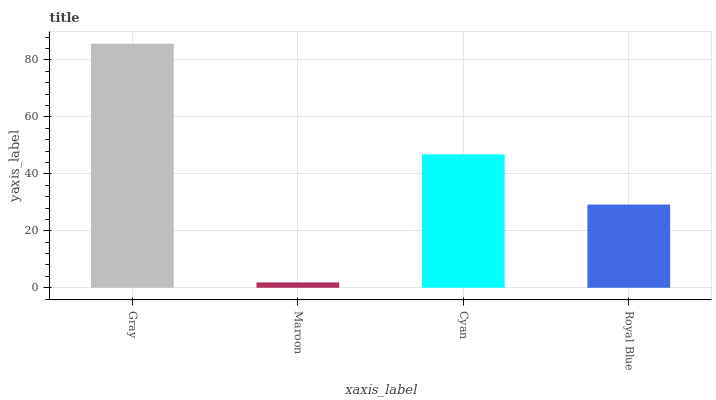Is Maroon the minimum?
Answer yes or no. Yes. Is Gray the maximum?
Answer yes or no. Yes. Is Cyan the minimum?
Answer yes or no. No. Is Cyan the maximum?
Answer yes or no. No. Is Cyan greater than Maroon?
Answer yes or no. Yes. Is Maroon less than Cyan?
Answer yes or no. Yes. Is Maroon greater than Cyan?
Answer yes or no. No. Is Cyan less than Maroon?
Answer yes or no. No. Is Cyan the high median?
Answer yes or no. Yes. Is Royal Blue the low median?
Answer yes or no. Yes. Is Royal Blue the high median?
Answer yes or no. No. Is Maroon the low median?
Answer yes or no. No. 